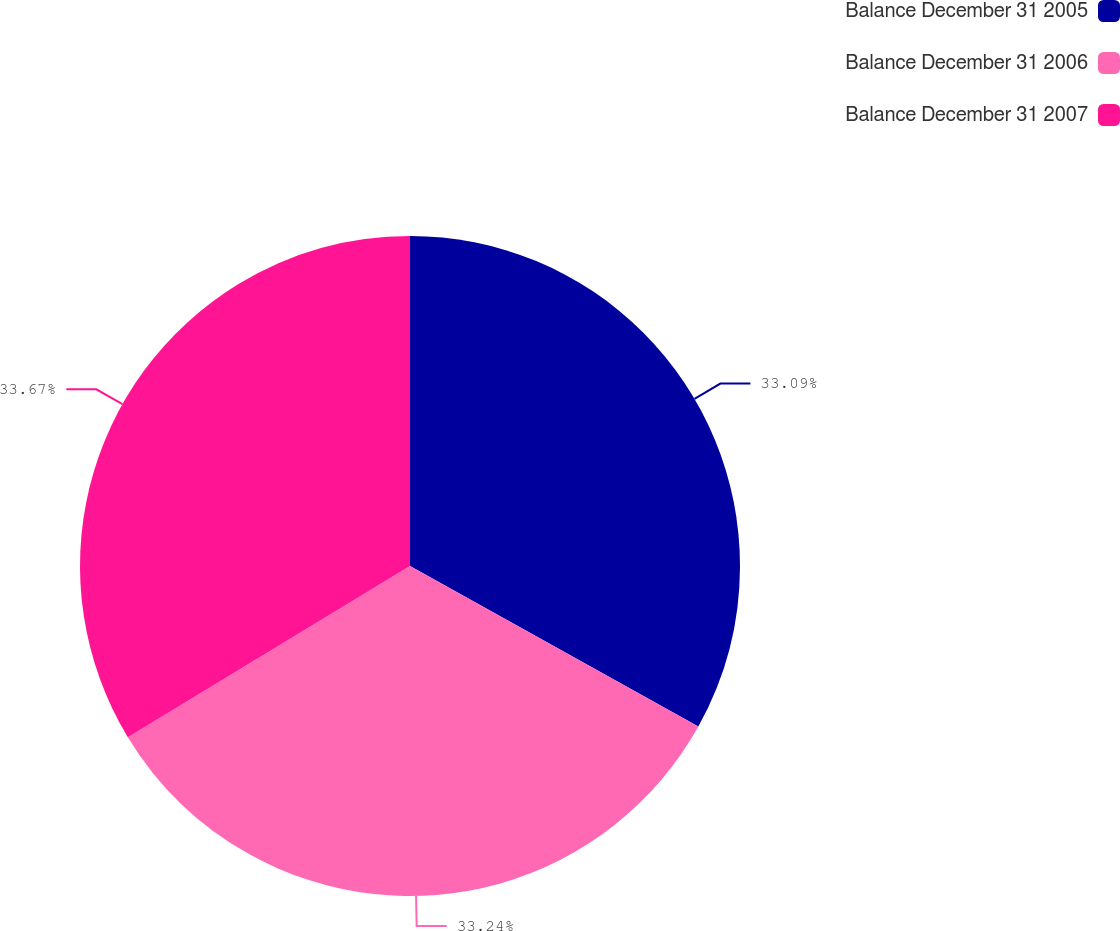<chart> <loc_0><loc_0><loc_500><loc_500><pie_chart><fcel>Balance December 31 2005<fcel>Balance December 31 2006<fcel>Balance December 31 2007<nl><fcel>33.09%<fcel>33.24%<fcel>33.68%<nl></chart> 